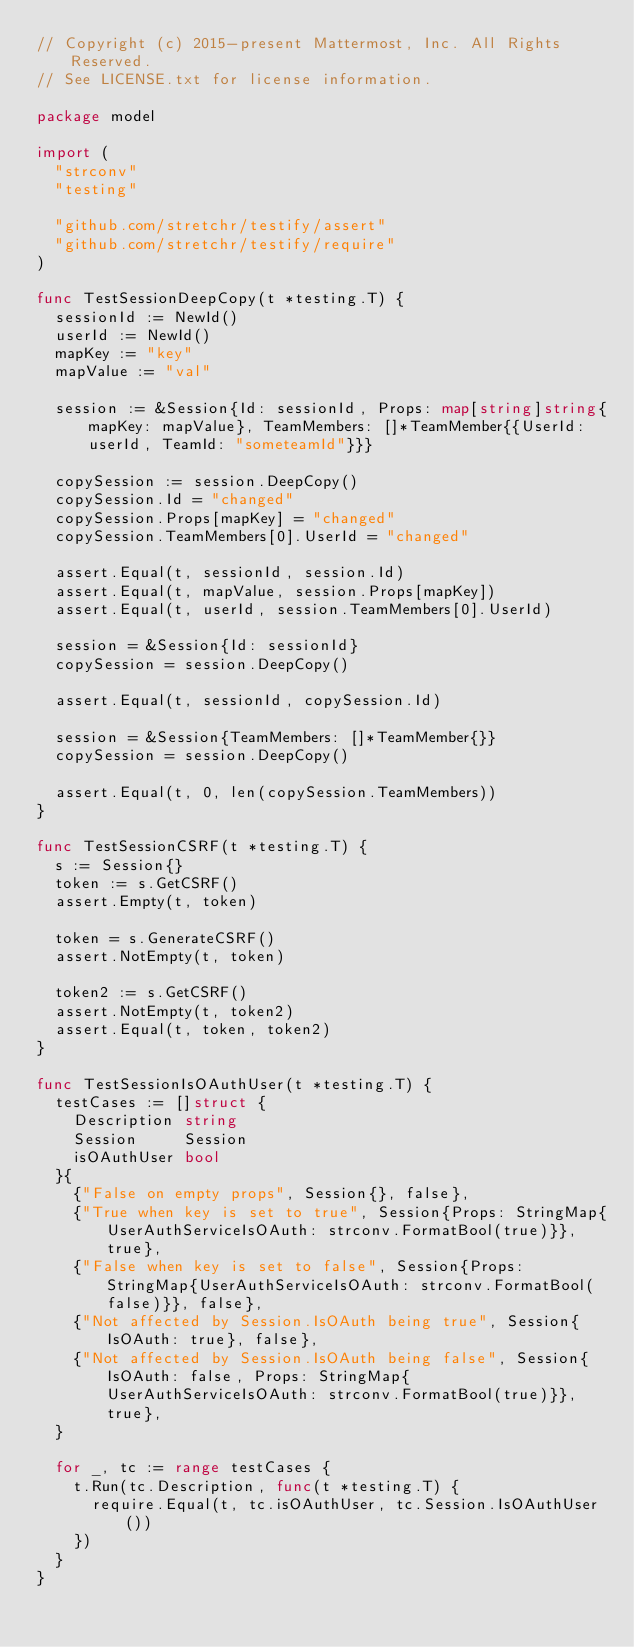Convert code to text. <code><loc_0><loc_0><loc_500><loc_500><_Go_>// Copyright (c) 2015-present Mattermost, Inc. All Rights Reserved.
// See LICENSE.txt for license information.

package model

import (
	"strconv"
	"testing"

	"github.com/stretchr/testify/assert"
	"github.com/stretchr/testify/require"
)

func TestSessionDeepCopy(t *testing.T) {
	sessionId := NewId()
	userId := NewId()
	mapKey := "key"
	mapValue := "val"

	session := &Session{Id: sessionId, Props: map[string]string{mapKey: mapValue}, TeamMembers: []*TeamMember{{UserId: userId, TeamId: "someteamId"}}}

	copySession := session.DeepCopy()
	copySession.Id = "changed"
	copySession.Props[mapKey] = "changed"
	copySession.TeamMembers[0].UserId = "changed"

	assert.Equal(t, sessionId, session.Id)
	assert.Equal(t, mapValue, session.Props[mapKey])
	assert.Equal(t, userId, session.TeamMembers[0].UserId)

	session = &Session{Id: sessionId}
	copySession = session.DeepCopy()

	assert.Equal(t, sessionId, copySession.Id)

	session = &Session{TeamMembers: []*TeamMember{}}
	copySession = session.DeepCopy()

	assert.Equal(t, 0, len(copySession.TeamMembers))
}

func TestSessionCSRF(t *testing.T) {
	s := Session{}
	token := s.GetCSRF()
	assert.Empty(t, token)

	token = s.GenerateCSRF()
	assert.NotEmpty(t, token)

	token2 := s.GetCSRF()
	assert.NotEmpty(t, token2)
	assert.Equal(t, token, token2)
}

func TestSessionIsOAuthUser(t *testing.T) {
	testCases := []struct {
		Description string
		Session     Session
		isOAuthUser bool
	}{
		{"False on empty props", Session{}, false},
		{"True when key is set to true", Session{Props: StringMap{UserAuthServiceIsOAuth: strconv.FormatBool(true)}}, true},
		{"False when key is set to false", Session{Props: StringMap{UserAuthServiceIsOAuth: strconv.FormatBool(false)}}, false},
		{"Not affected by Session.IsOAuth being true", Session{IsOAuth: true}, false},
		{"Not affected by Session.IsOAuth being false", Session{IsOAuth: false, Props: StringMap{UserAuthServiceIsOAuth: strconv.FormatBool(true)}}, true},
	}

	for _, tc := range testCases {
		t.Run(tc.Description, func(t *testing.T) {
			require.Equal(t, tc.isOAuthUser, tc.Session.IsOAuthUser())
		})
	}
}
</code> 